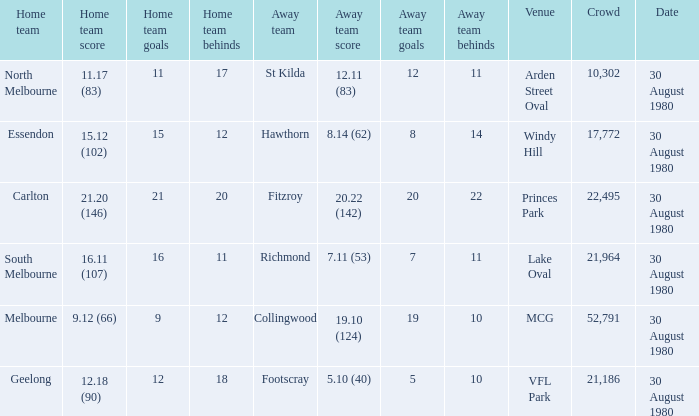What is the home team score at lake oval? 16.11 (107). 